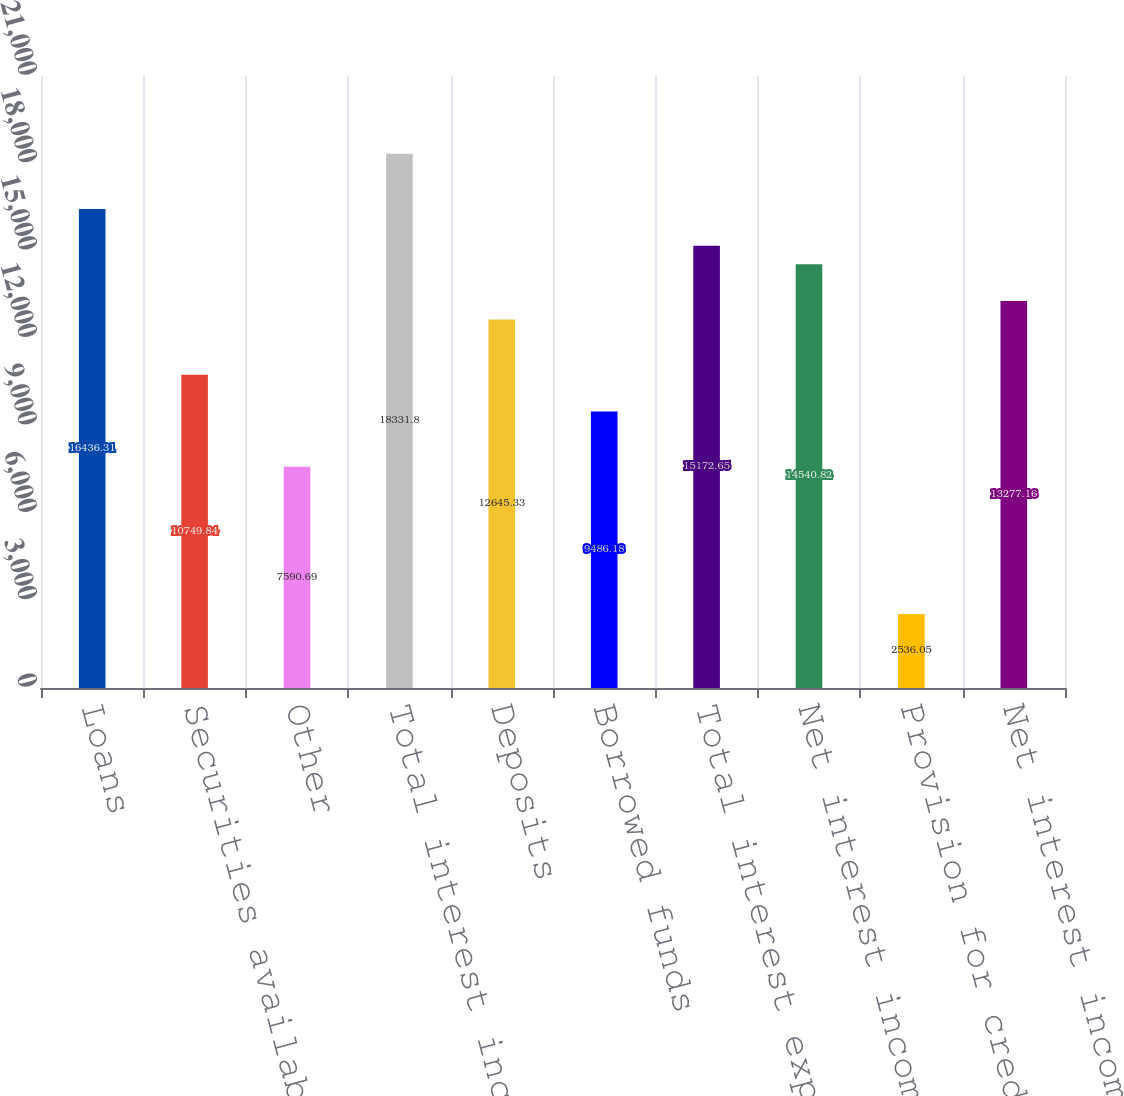<chart> <loc_0><loc_0><loc_500><loc_500><bar_chart><fcel>Loans<fcel>Securities available for sale<fcel>Other<fcel>Total interest income<fcel>Deposits<fcel>Borrowed funds<fcel>Total interest expense<fcel>Net interest income<fcel>Provision for credit losses<fcel>Net interest income less<nl><fcel>16436.3<fcel>10749.8<fcel>7590.69<fcel>18331.8<fcel>12645.3<fcel>9486.18<fcel>15172.6<fcel>14540.8<fcel>2536.05<fcel>13277.2<nl></chart> 